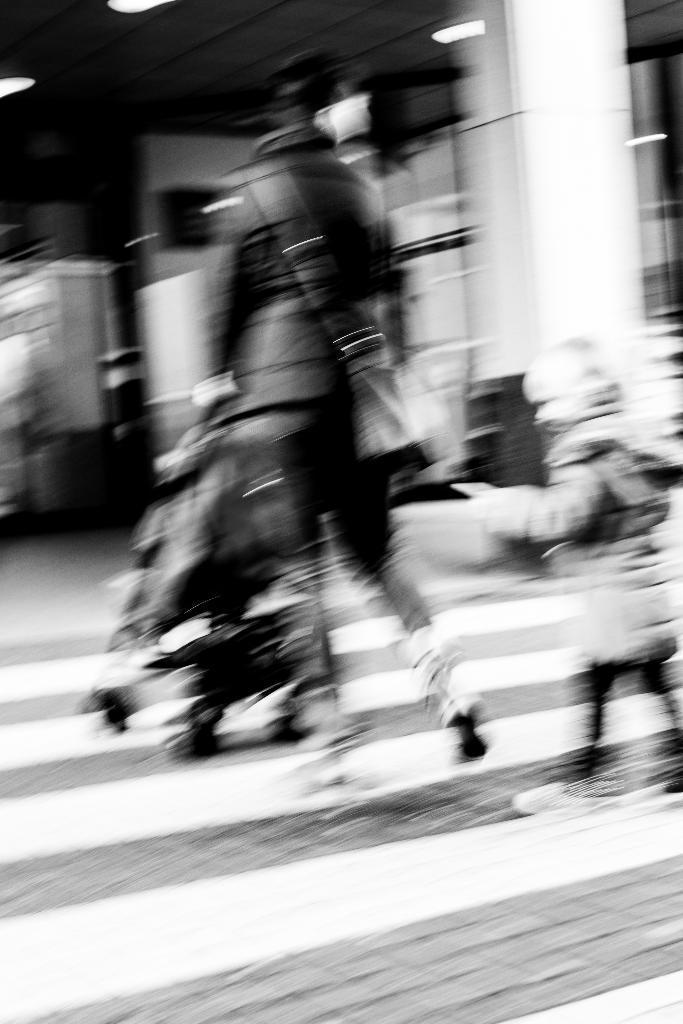How would you summarize this image in a sentence or two? This picture is blur, in this picture we can see people, stroller, lights and objects. 